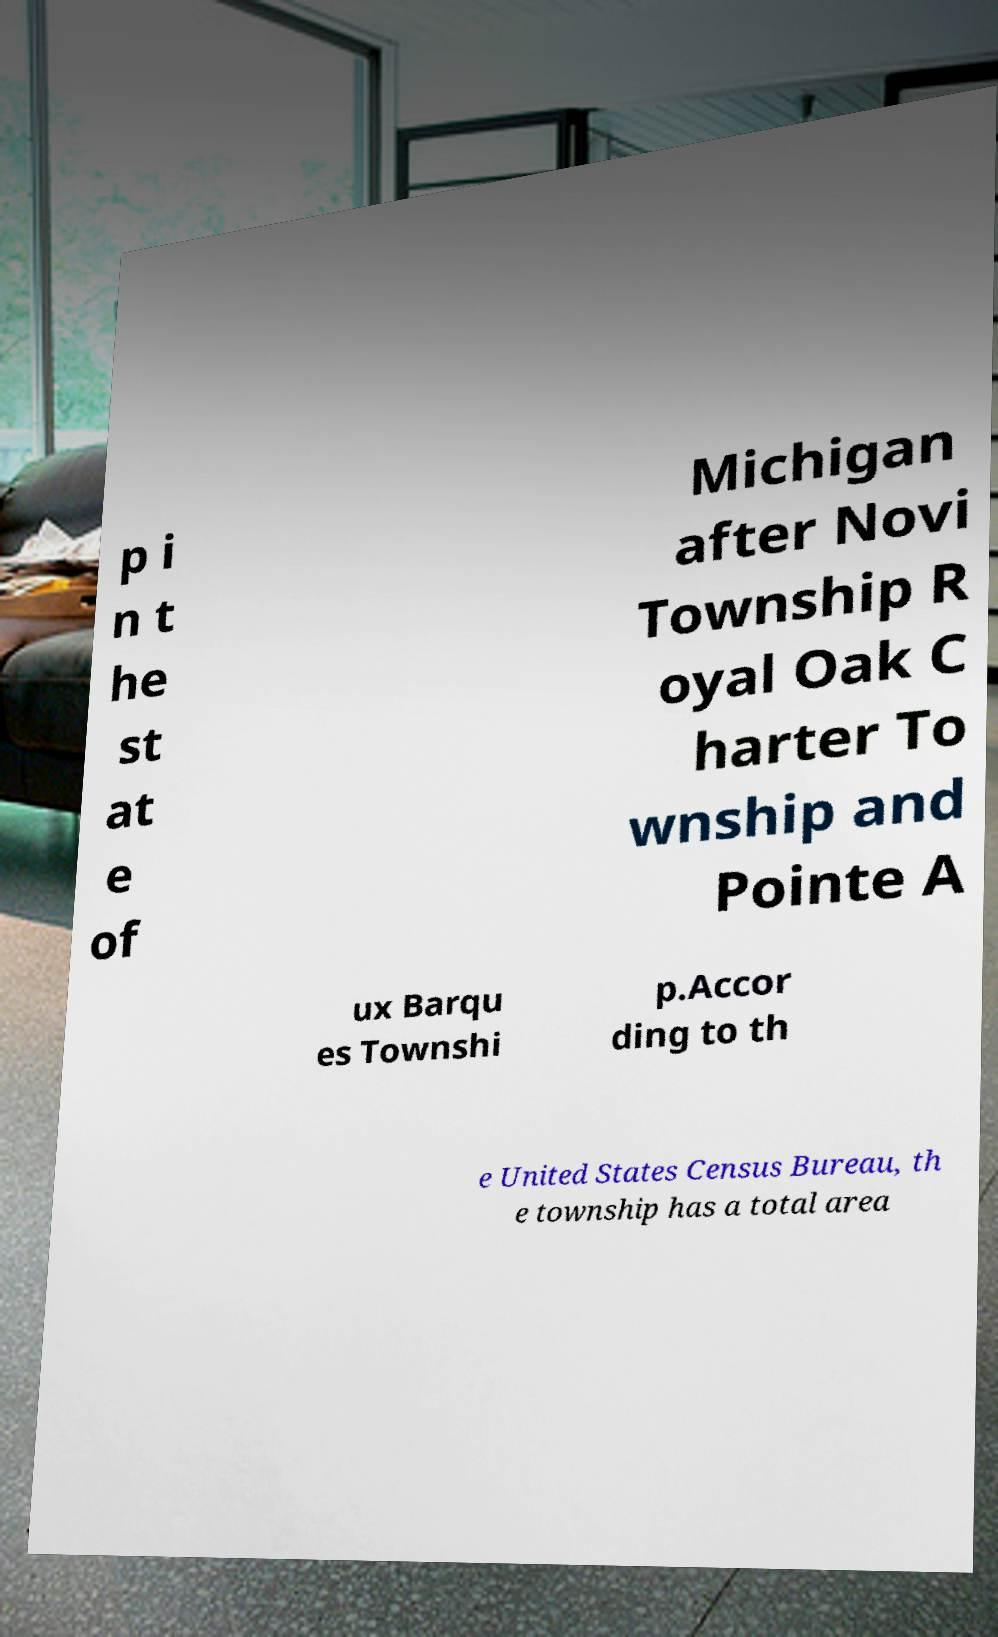Please read and relay the text visible in this image. What does it say? p i n t he st at e of Michigan after Novi Township R oyal Oak C harter To wnship and Pointe A ux Barqu es Townshi p.Accor ding to th e United States Census Bureau, th e township has a total area 